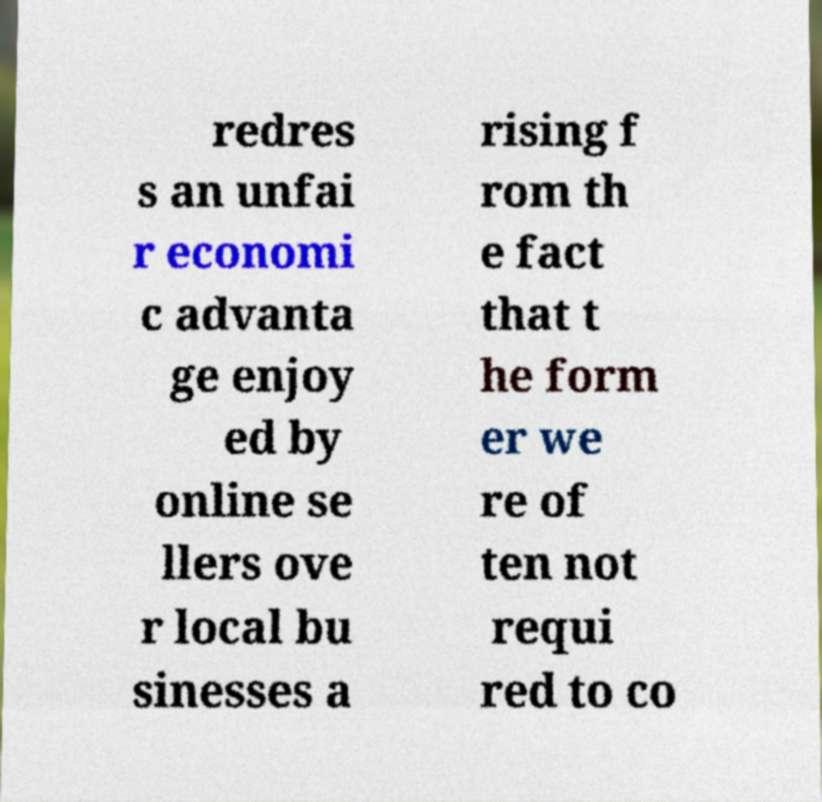Please read and relay the text visible in this image. What does it say? redres s an unfai r economi c advanta ge enjoy ed by online se llers ove r local bu sinesses a rising f rom th e fact that t he form er we re of ten not requi red to co 